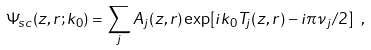<formula> <loc_0><loc_0><loc_500><loc_500>\Psi _ { s c } ( z , r ; k _ { 0 } ) = \sum _ { j } A _ { j } ( z , r ) \exp [ i k _ { 0 } T _ { j } ( z , r ) - i \pi \nu _ { j } / 2 ] \ ,</formula> 